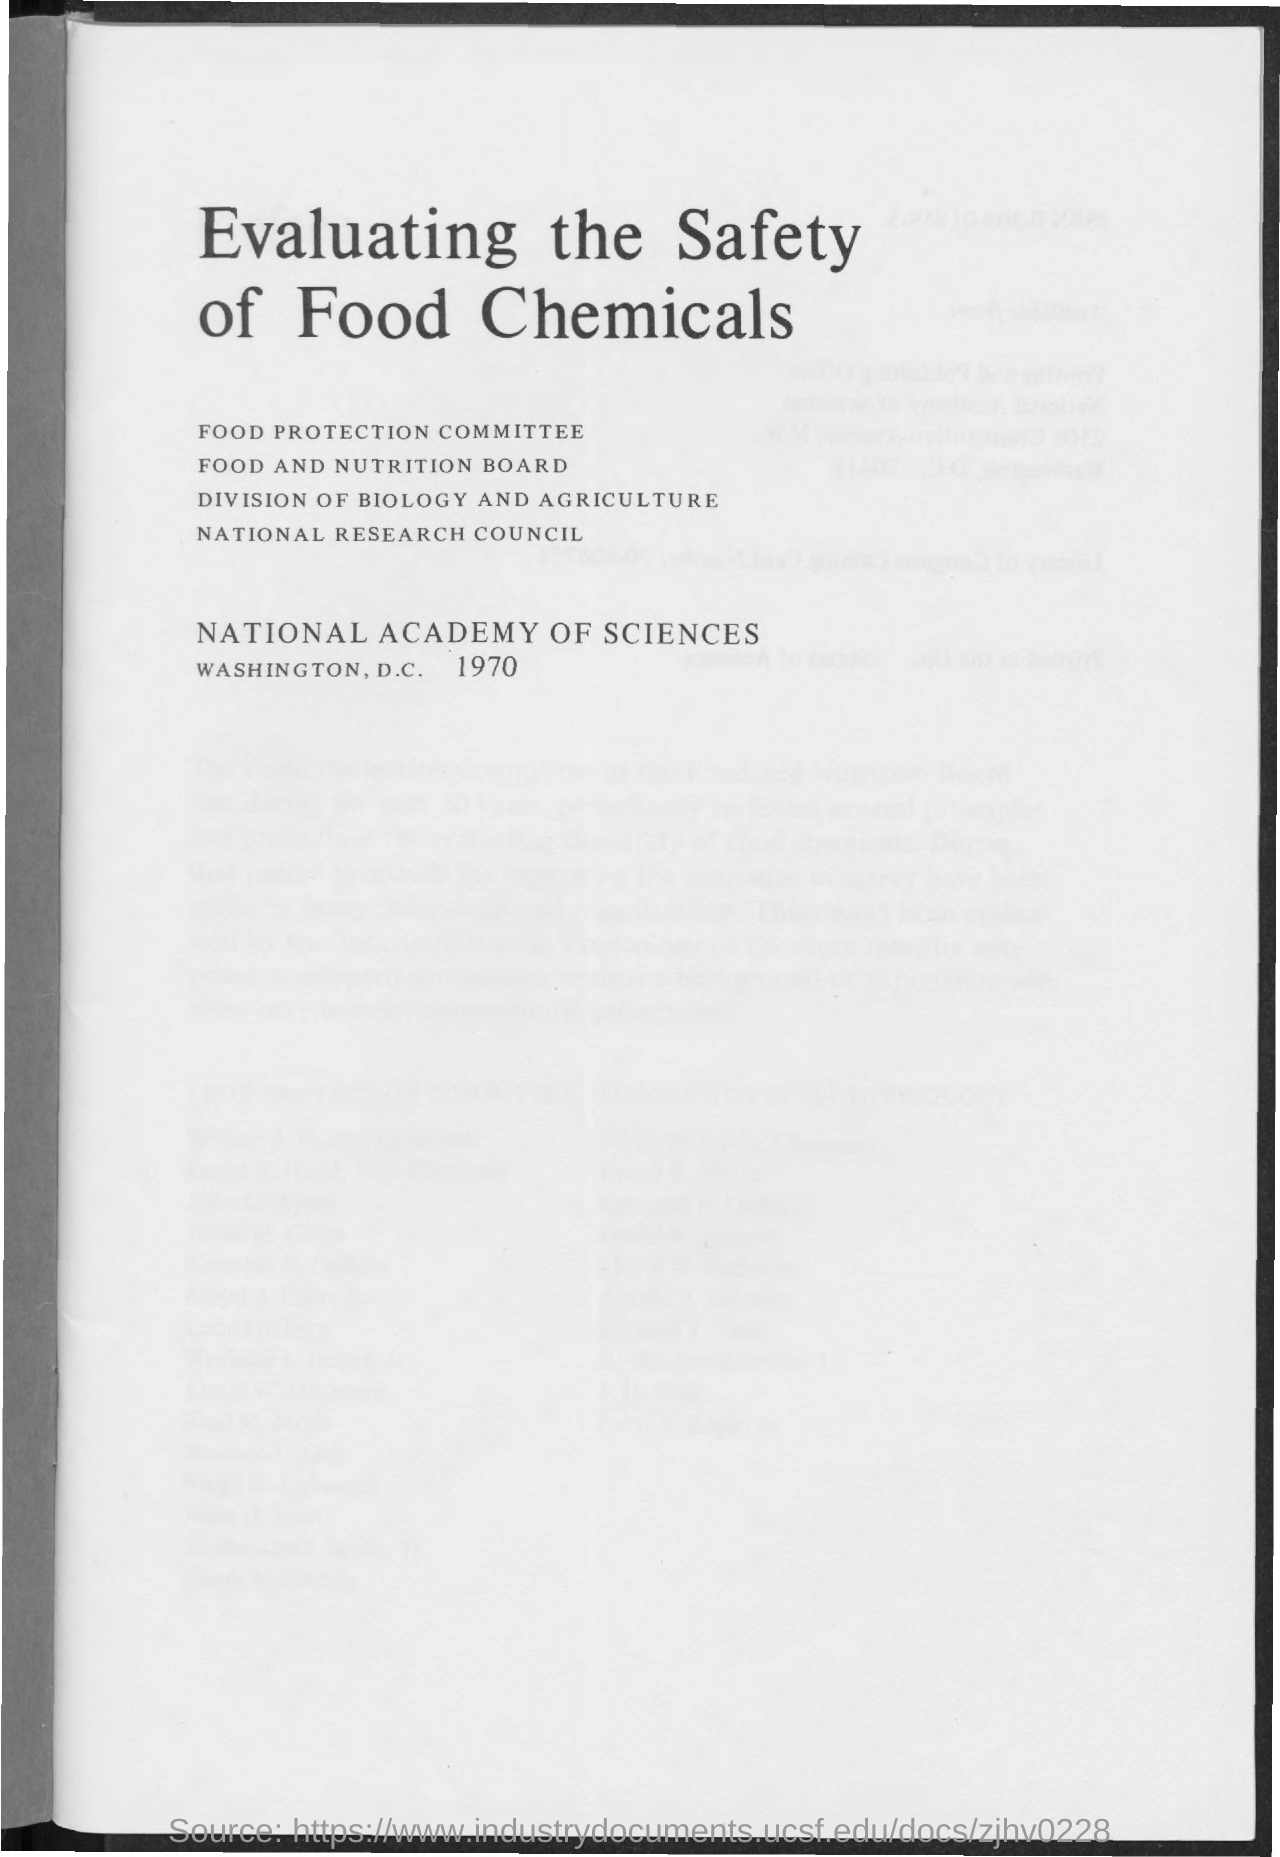What is the title of the document?
Ensure brevity in your answer.  Evaluating the safety of food chemicals. What is the year mentioned in the document?
Ensure brevity in your answer.  1970. 